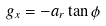<formula> <loc_0><loc_0><loc_500><loc_500>g _ { x } = - a _ { r } \tan { \phi }</formula> 